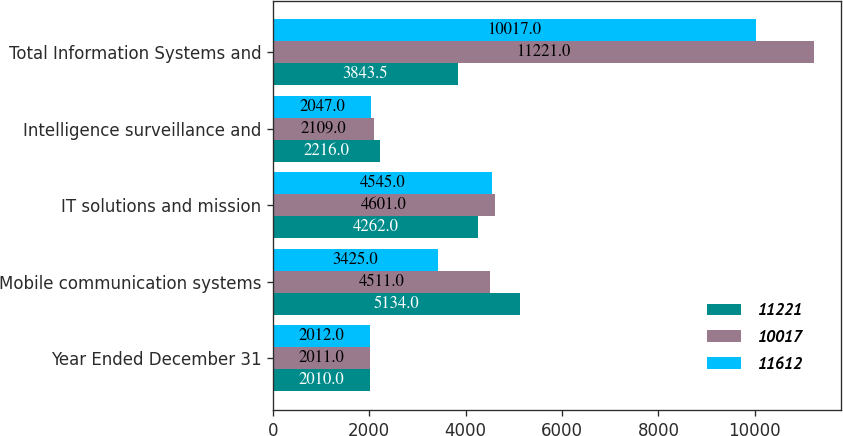Convert chart. <chart><loc_0><loc_0><loc_500><loc_500><stacked_bar_chart><ecel><fcel>Year Ended December 31<fcel>Mobile communication systems<fcel>IT solutions and mission<fcel>Intelligence surveillance and<fcel>Total Information Systems and<nl><fcel>11221<fcel>2010<fcel>5134<fcel>4262<fcel>2216<fcel>3843.5<nl><fcel>10017<fcel>2011<fcel>4511<fcel>4601<fcel>2109<fcel>11221<nl><fcel>11612<fcel>2012<fcel>3425<fcel>4545<fcel>2047<fcel>10017<nl></chart> 